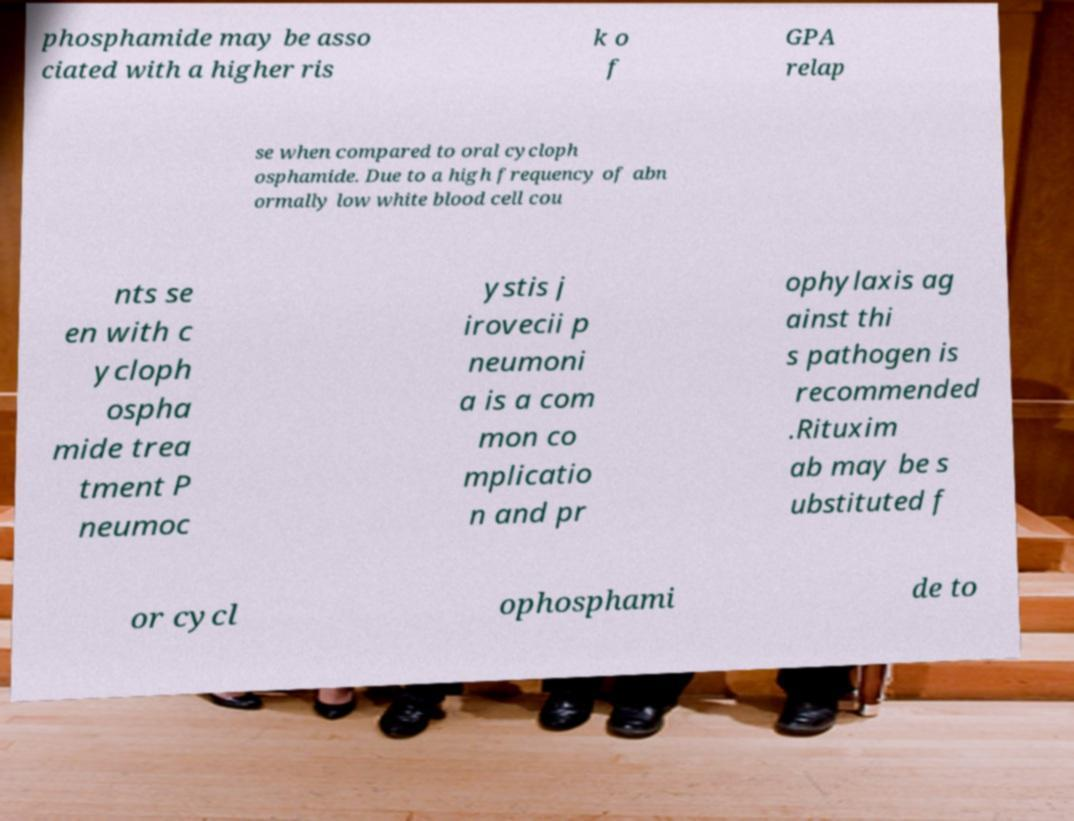Could you assist in decoding the text presented in this image and type it out clearly? phosphamide may be asso ciated with a higher ris k o f GPA relap se when compared to oral cycloph osphamide. Due to a high frequency of abn ormally low white blood cell cou nts se en with c ycloph ospha mide trea tment P neumoc ystis j irovecii p neumoni a is a com mon co mplicatio n and pr ophylaxis ag ainst thi s pathogen is recommended .Rituxim ab may be s ubstituted f or cycl ophosphami de to 